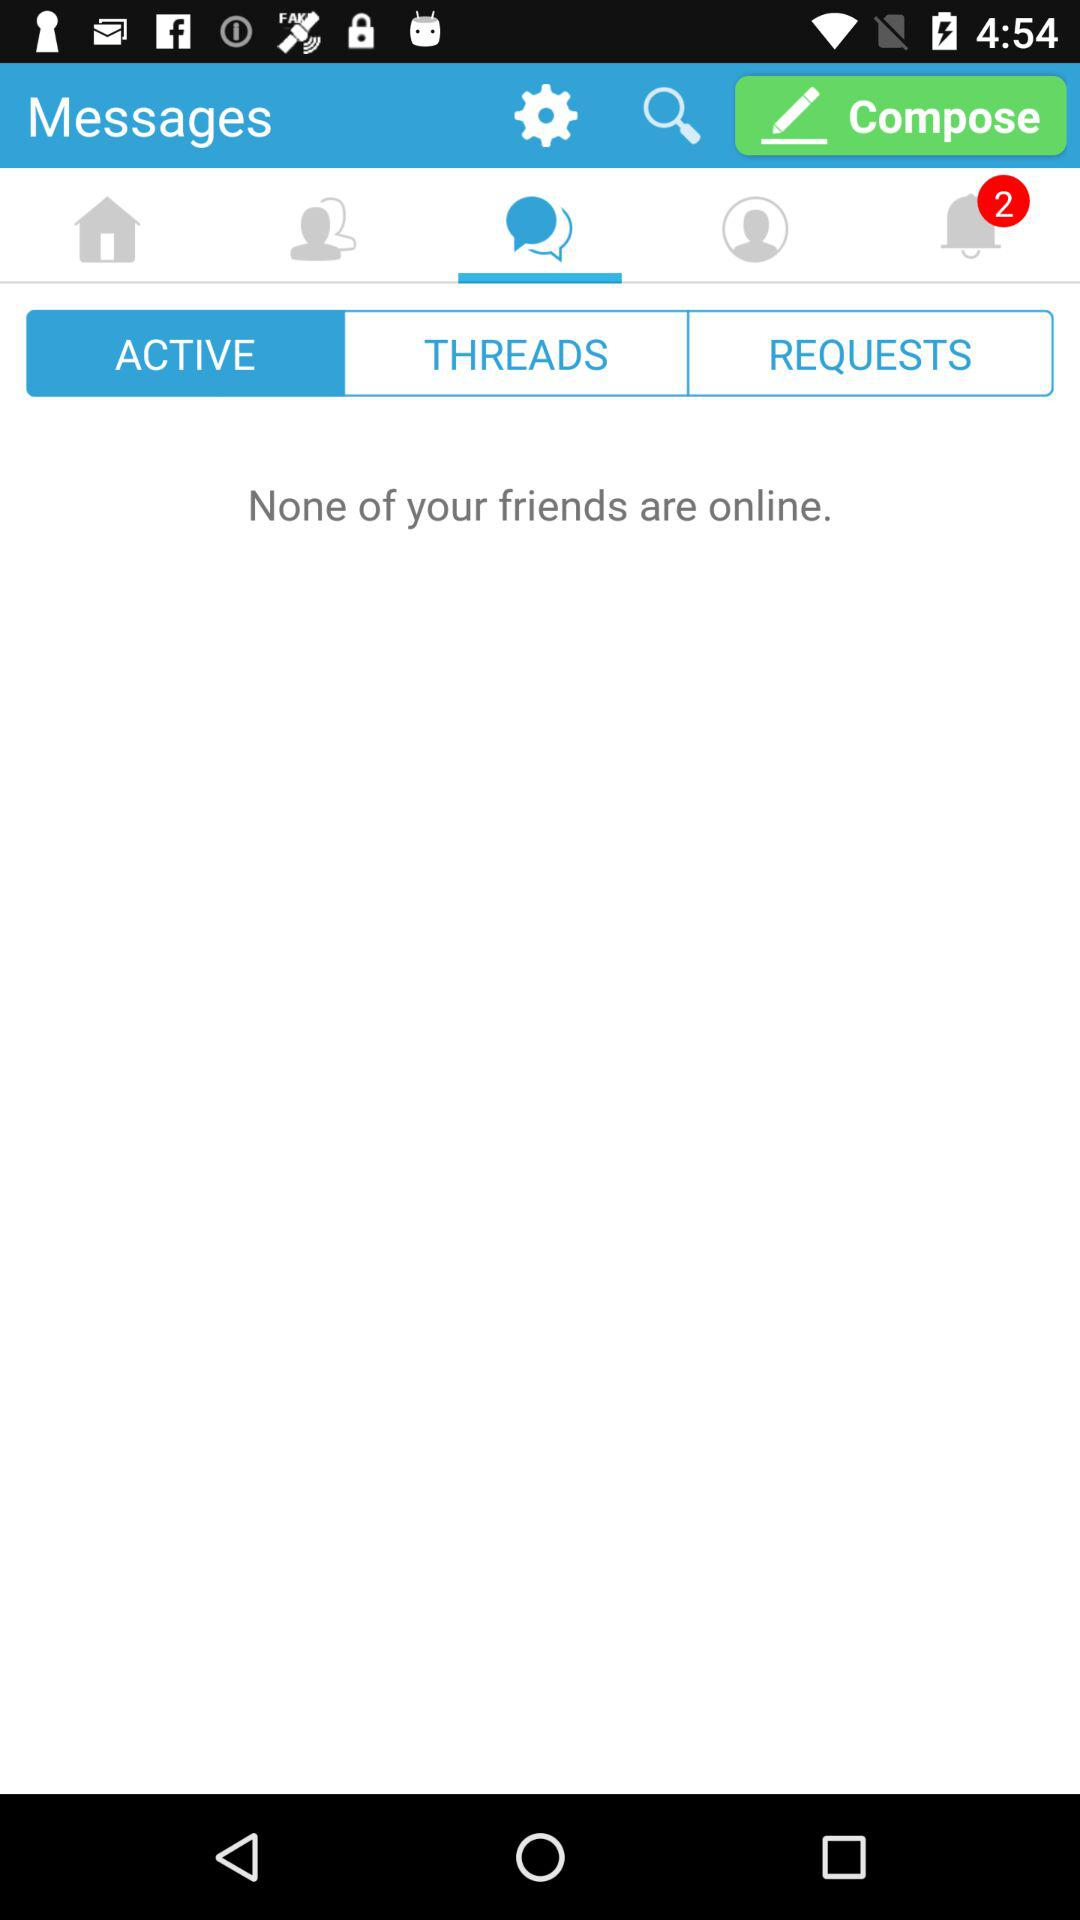How many unread notifications are there? There are 2 unread notifications. 